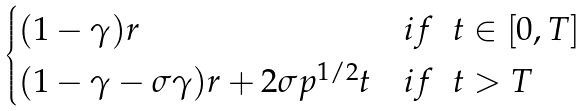<formula> <loc_0><loc_0><loc_500><loc_500>\begin{cases} ( 1 - \gamma ) r & i f \ \ t \in [ 0 , T ] \\ ( 1 - \gamma - \sigma \gamma ) r + 2 \sigma p ^ { 1 / 2 } t & i f \ \ t > T \end{cases}</formula> 